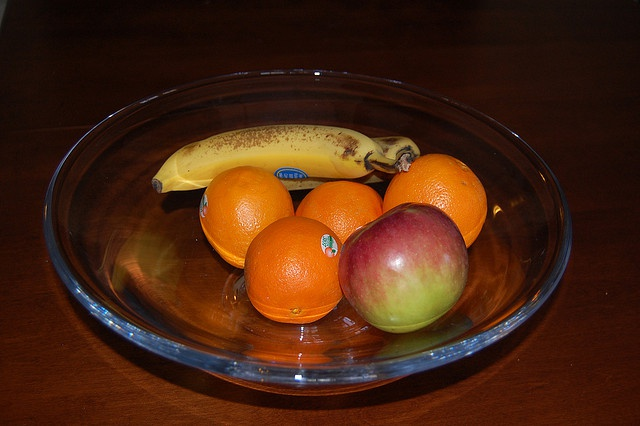Describe the objects in this image and their specific colors. I can see bowl in black, maroon, red, and brown tones, apple in black, maroon, tan, and brown tones, banana in black, tan, olive, and orange tones, orange in black, red, brown, and orange tones, and orange in black, red, and orange tones in this image. 